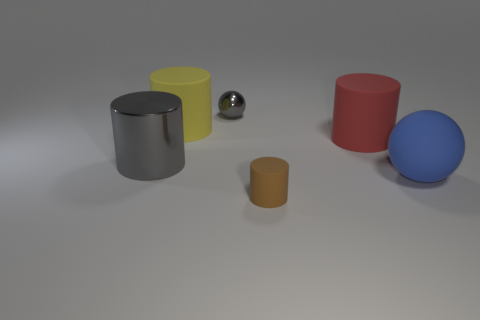How many metallic objects are the same color as the small sphere?
Your response must be concise. 1. Do the tiny thing that is behind the brown cylinder and the tiny object that is in front of the big matte ball have the same material?
Offer a very short reply. No. Is there another tiny matte object that has the same shape as the yellow rubber object?
Give a very brief answer. Yes. What number of objects are cylinders that are in front of the blue matte object or tiny yellow shiny balls?
Keep it short and to the point. 1. Are there more objects that are behind the small rubber cylinder than small metallic balls right of the blue object?
Make the answer very short. Yes. How many matte objects are big yellow objects or large blue objects?
Your response must be concise. 2. There is another thing that is the same color as the tiny metallic thing; what is its material?
Ensure brevity in your answer.  Metal. Are there fewer big gray cylinders to the right of the brown cylinder than tiny things in front of the gray cylinder?
Make the answer very short. Yes. How many objects are blue matte objects or objects that are left of the large matte sphere?
Provide a short and direct response. 6. There is a gray thing that is the same size as the blue rubber sphere; what is it made of?
Give a very brief answer. Metal. 